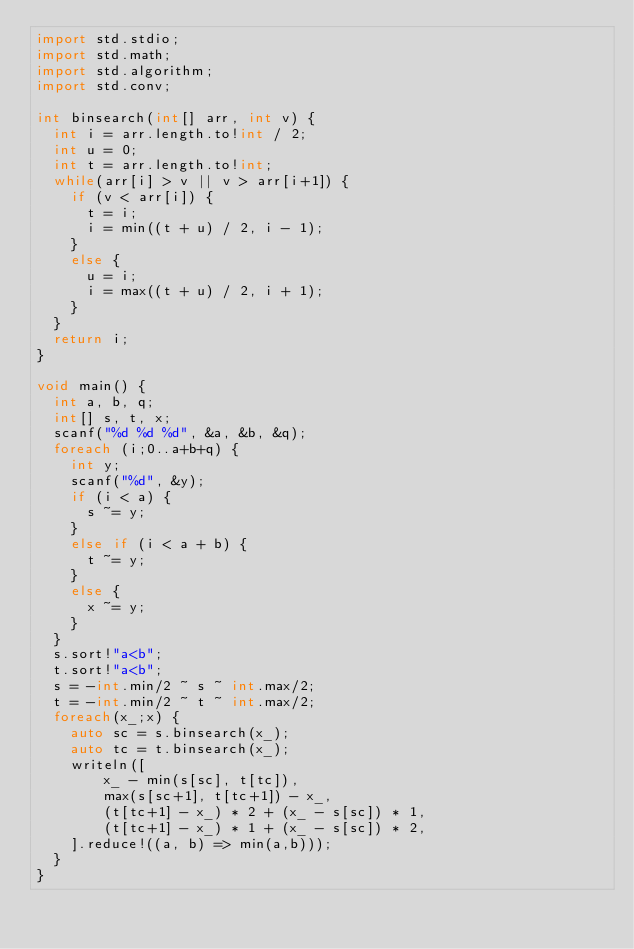<code> <loc_0><loc_0><loc_500><loc_500><_D_>import std.stdio;
import std.math;
import std.algorithm;
import std.conv;

int binsearch(int[] arr, int v) {
	int i = arr.length.to!int / 2;
	int u = 0;
	int t = arr.length.to!int;
	while(arr[i] > v || v > arr[i+1]) {
		if (v < arr[i]) {
			t = i;
			i = min((t + u) / 2, i - 1);
		}
		else {
			u = i;
			i = max((t + u) / 2, i + 1);
		}
	}
	return i;
}

void main() {
	int a, b, q;
	int[] s, t, x;
	scanf("%d %d %d", &a, &b, &q);
	foreach (i;0..a+b+q) {
		int y;
		scanf("%d", &y);
		if (i < a) {
			s ~= y;
		}
		else if (i < a + b) {
			t ~= y;
		}
		else {
			x ~= y;
		}
	}
	s.sort!"a<b";
	t.sort!"a<b";
	s = -int.min/2 ~ s ~ int.max/2;
	t = -int.min/2 ~ t ~ int.max/2;
	foreach(x_;x) {
		auto sc = s.binsearch(x_);
		auto tc = t.binsearch(x_);
		writeln([
				x_ - min(s[sc], t[tc]),
				max(s[sc+1], t[tc+1]) - x_,
				(t[tc+1] - x_) * 2 + (x_ - s[sc]) * 1,
				(t[tc+1] - x_) * 1 + (x_ - s[sc]) * 2,
		].reduce!((a, b) => min(a,b)));
	}
}
</code> 